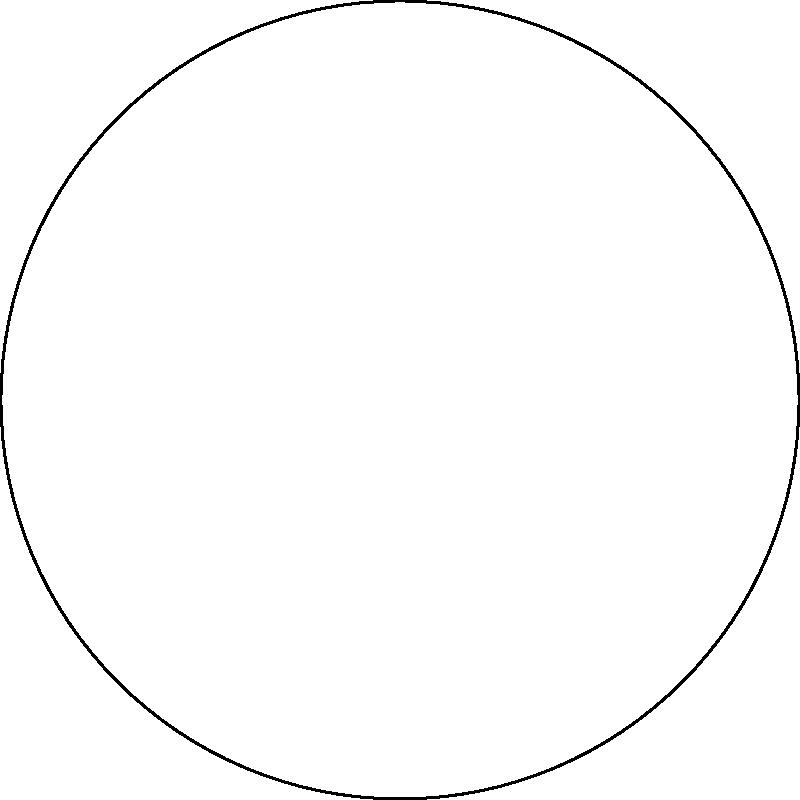In the context of personal growth journeys represented on an elliptic geometry model, two children start at point A and end at point B. If these paths represent parallel lines in elliptic geometry, what can we conclude about their journeys and how might this relate to developing positive self-esteem? To answer this question, let's break it down step-by-step:

1. In elliptic geometry, parallel lines are defined differently than in Euclidean geometry. They are great circles that intersect at two antipodal points.

2. In the diagram, we see two paths (blue and red) connecting points A and B on a sphere (represented by the circle). These paths are actually arcs of great circles.

3. These two paths, despite starting and ending at the same points, take different routes. This is a key feature of elliptic geometry - there are no truly parallel lines that never intersect.

4. In the context of personal growth:
   a) The two paths represent different journeys of personal development for two children.
   b) Both start at the same point (A) and reach the same destination (B), symbolizing similar starting points and goals in building self-esteem.
   c) The different routes taken illustrate that personal growth is not a one-size-fits-all process.

5. Relating to positive self-esteem development:
   a) Each child's journey is unique, even if the end goal (positive self-esteem) is the same.
   b) There's no single "correct" path to developing self-esteem.
   c) The intersecting nature of the paths suggests that children's journeys may overlap or influence each other at times.

6. The elliptic model emphasizes that all paths eventually reconnect, reinforcing the idea that diverse approaches to building self-esteem can all lead to positive outcomes.
Answer: Different paths can lead to the same positive outcome in self-esteem development, emphasizing individuality in personal growth journeys. 